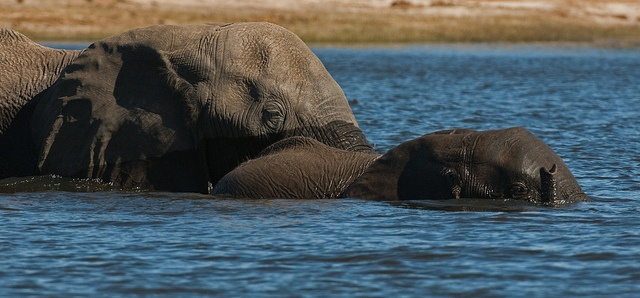Describe the objects in this image and their specific colors. I can see elephant in tan, black, and gray tones and elephant in tan, black, and gray tones in this image. 